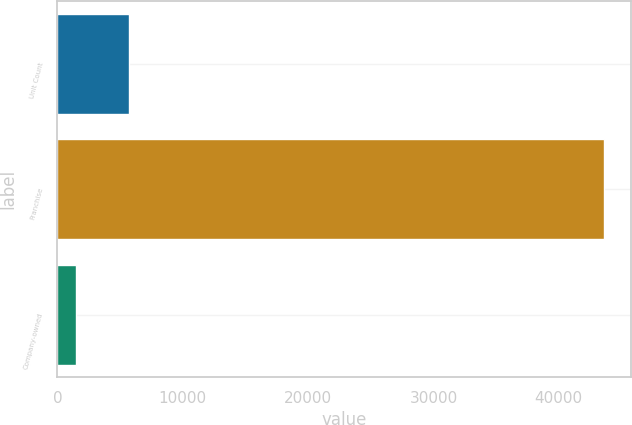Convert chart. <chart><loc_0><loc_0><loc_500><loc_500><bar_chart><fcel>Unit Count<fcel>Franchise<fcel>Company-owned<nl><fcel>5693.2<fcel>43603<fcel>1481<nl></chart> 